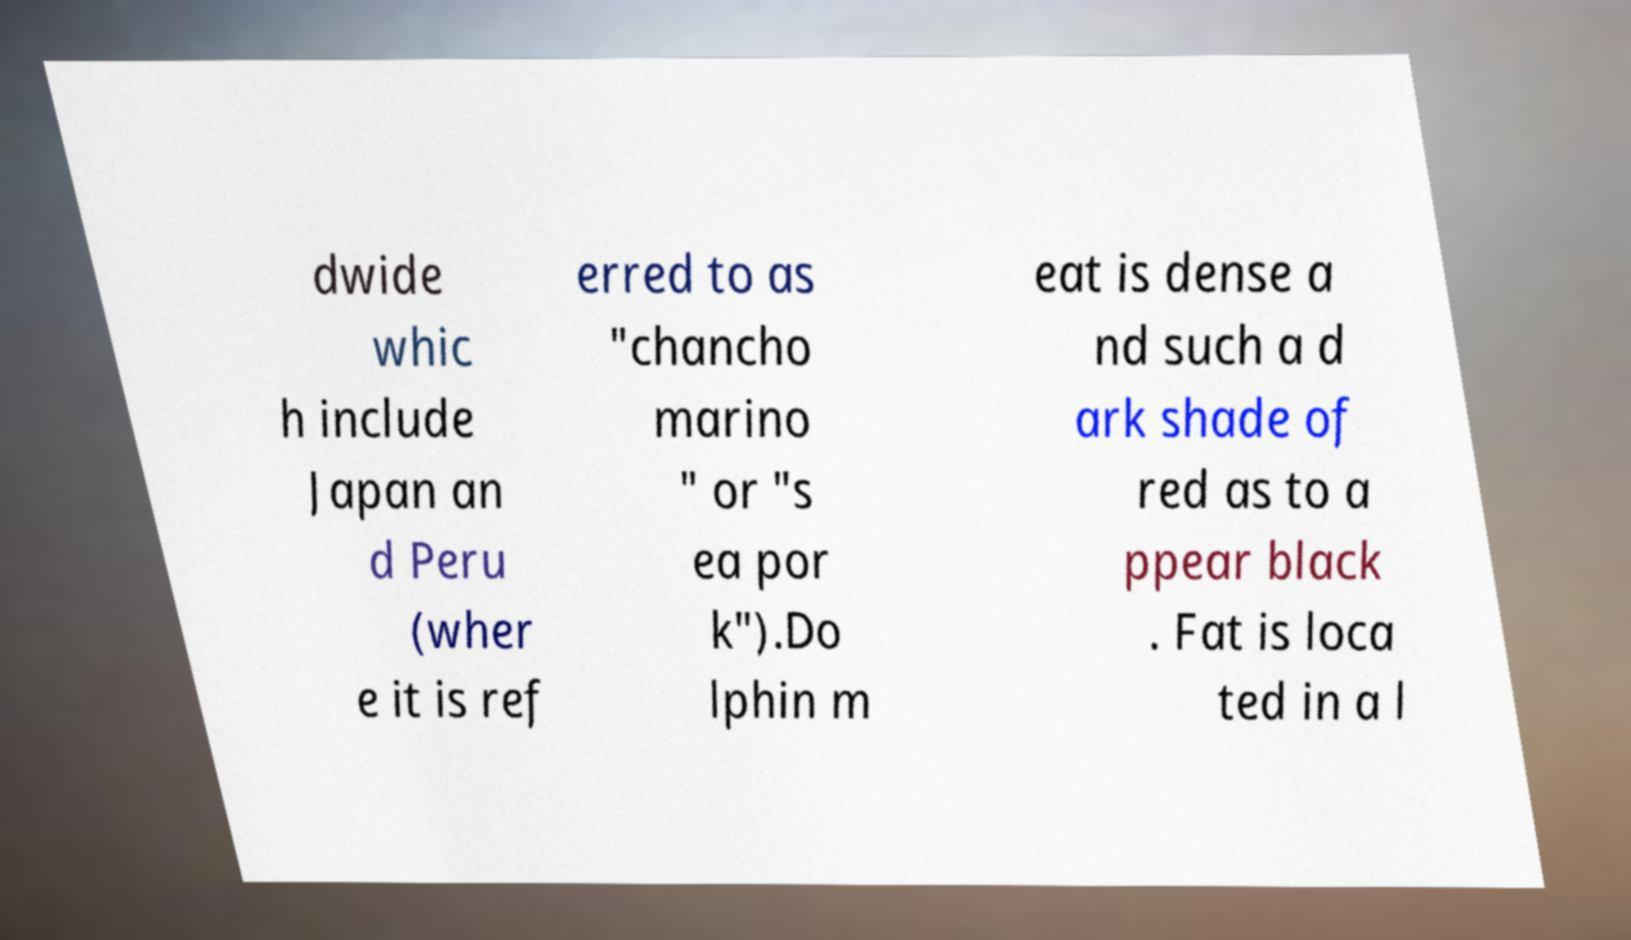I need the written content from this picture converted into text. Can you do that? dwide whic h include Japan an d Peru (wher e it is ref erred to as "chancho marino " or "s ea por k").Do lphin m eat is dense a nd such a d ark shade of red as to a ppear black . Fat is loca ted in a l 